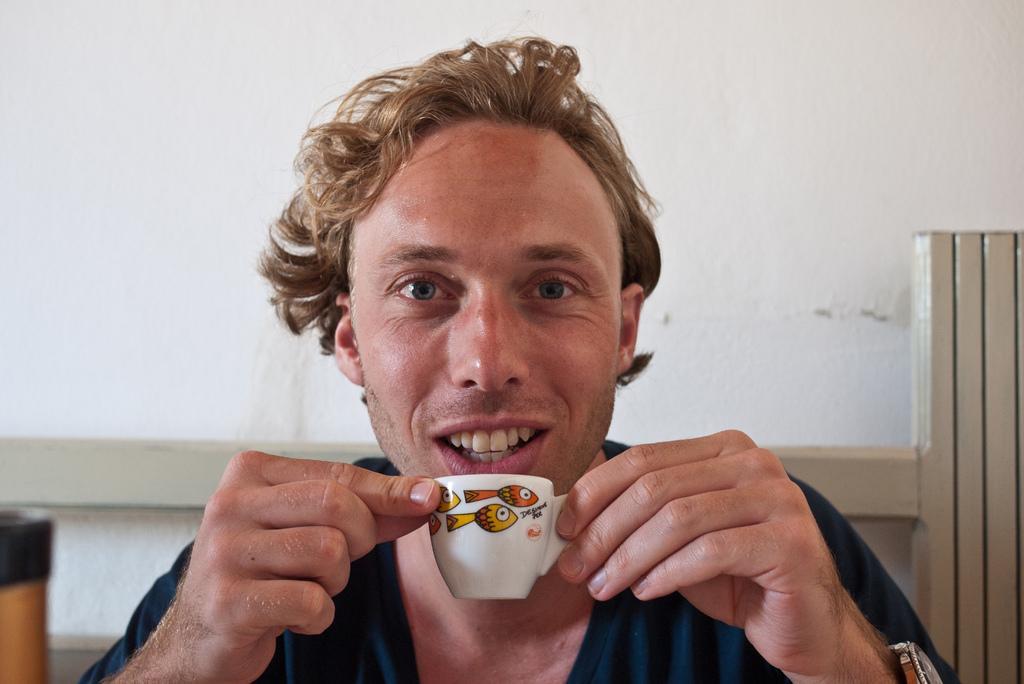Could you give a brief overview of what you see in this image? In this image, In the middle there is a man sitting and he is holding a cup which is in white color, In the background there is a white color wall. 